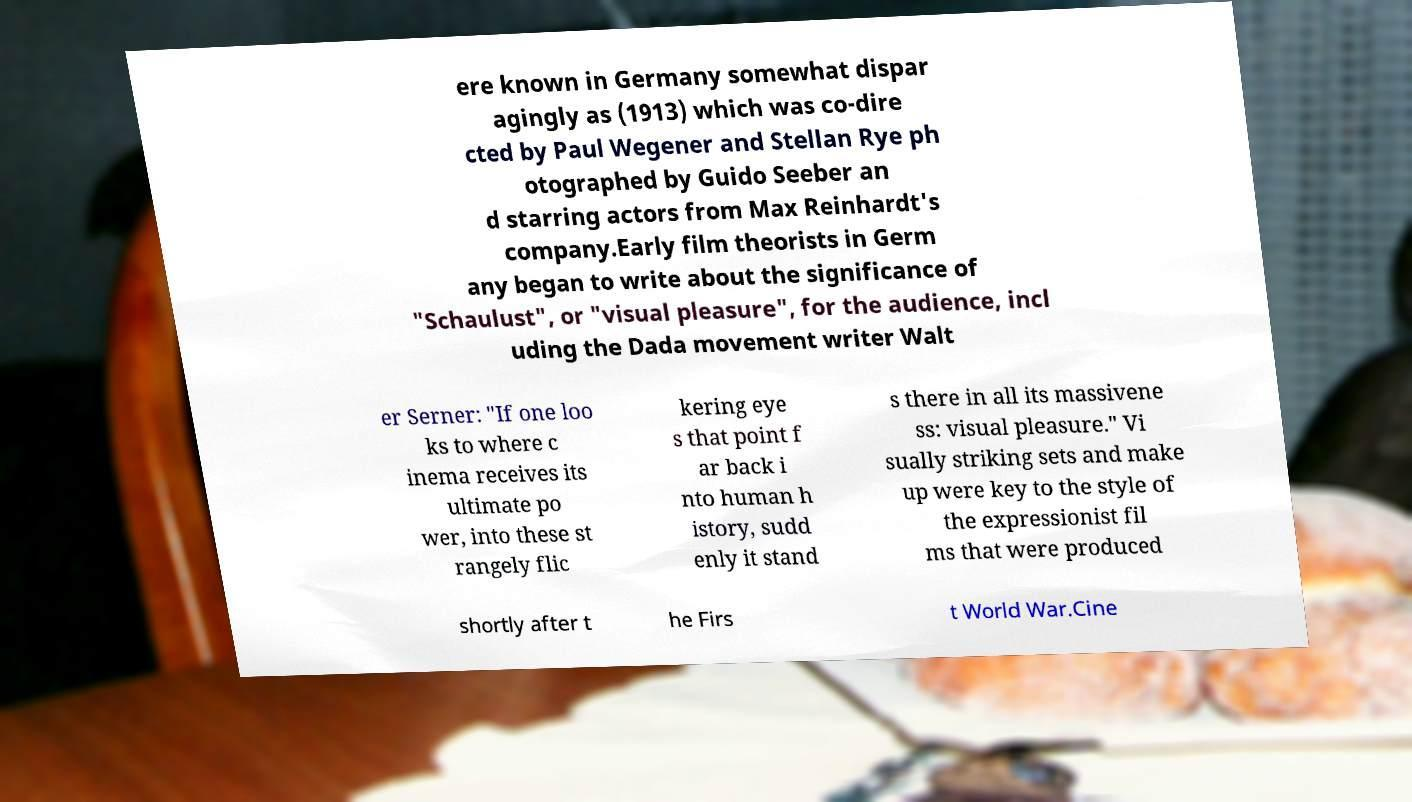Please identify and transcribe the text found in this image. ere known in Germany somewhat dispar agingly as (1913) which was co-dire cted by Paul Wegener and Stellan Rye ph otographed by Guido Seeber an d starring actors from Max Reinhardt's company.Early film theorists in Germ any began to write about the significance of "Schaulust", or "visual pleasure", for the audience, incl uding the Dada movement writer Walt er Serner: "If one loo ks to where c inema receives its ultimate po wer, into these st rangely flic kering eye s that point f ar back i nto human h istory, sudd enly it stand s there in all its massivene ss: visual pleasure." Vi sually striking sets and make up were key to the style of the expressionist fil ms that were produced shortly after t he Firs t World War.Cine 